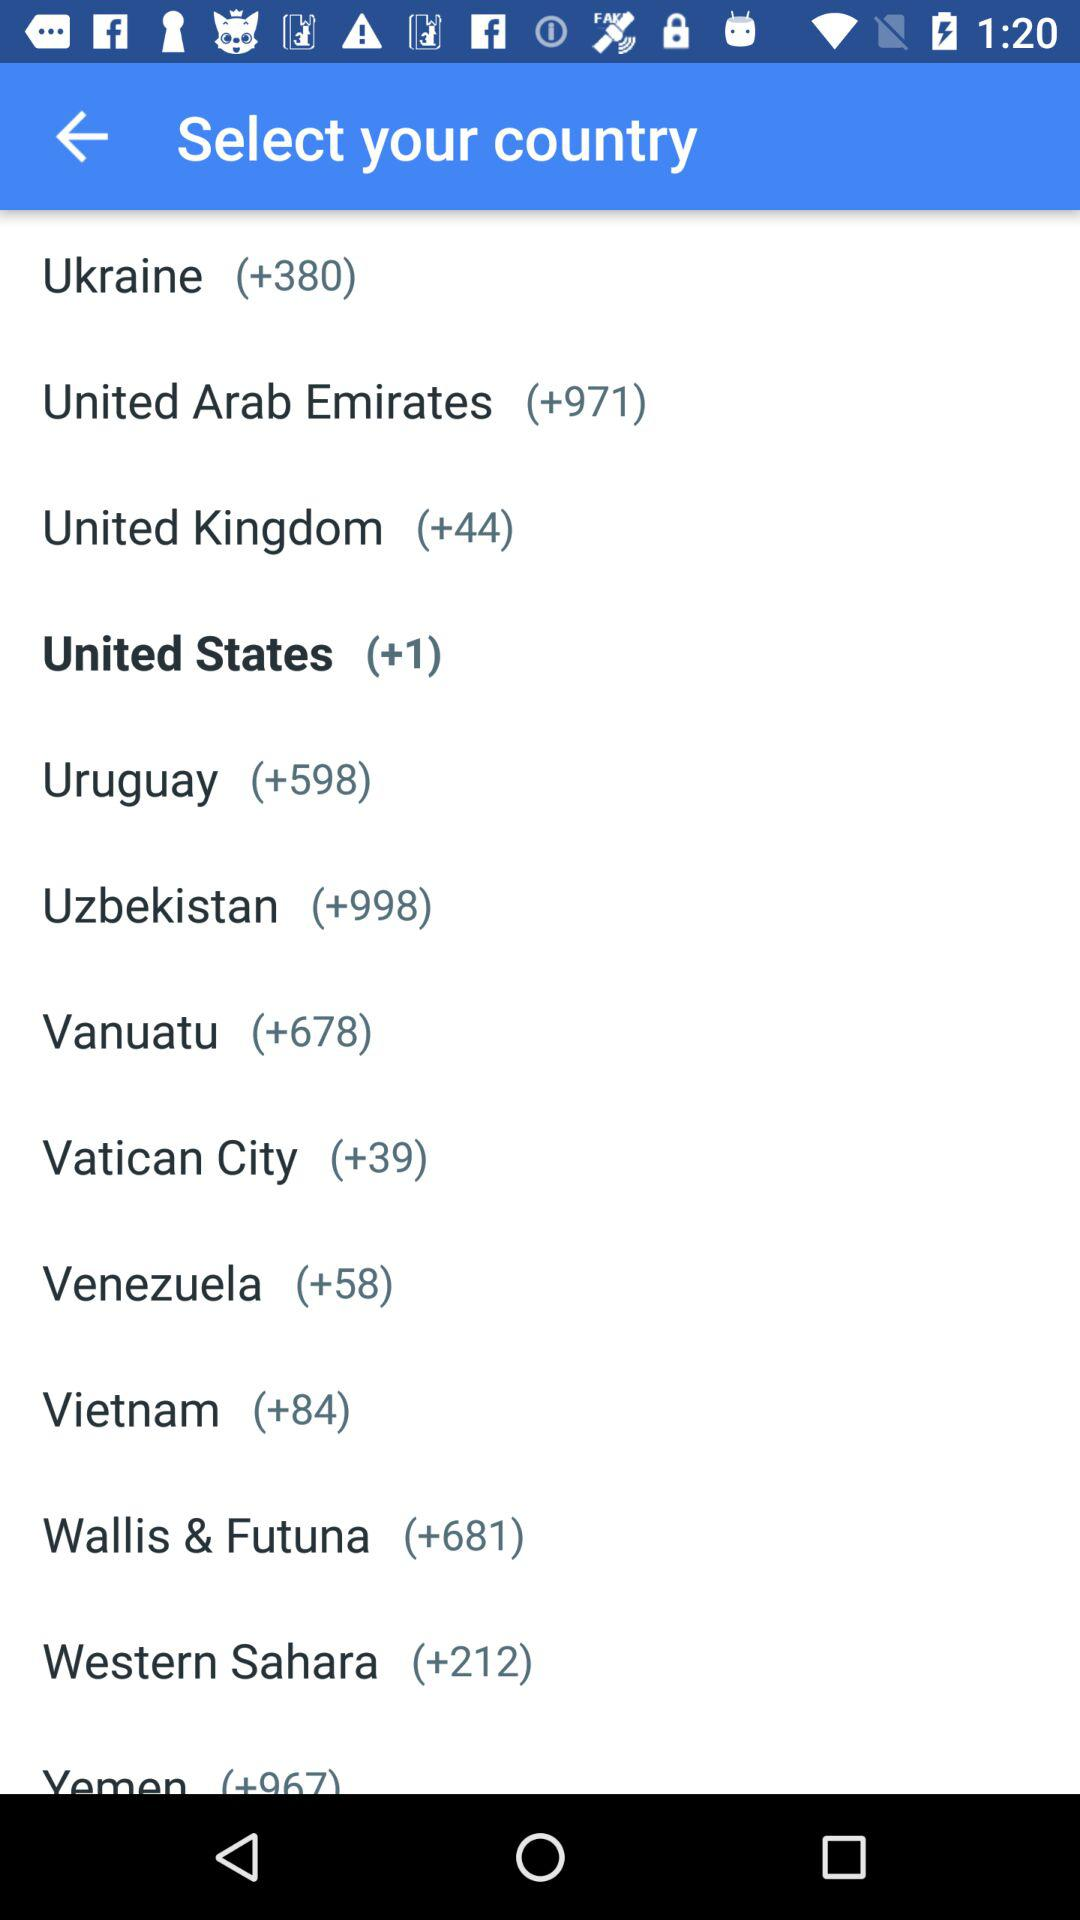What country is highlighted in black? The highlighted country is the United States. 